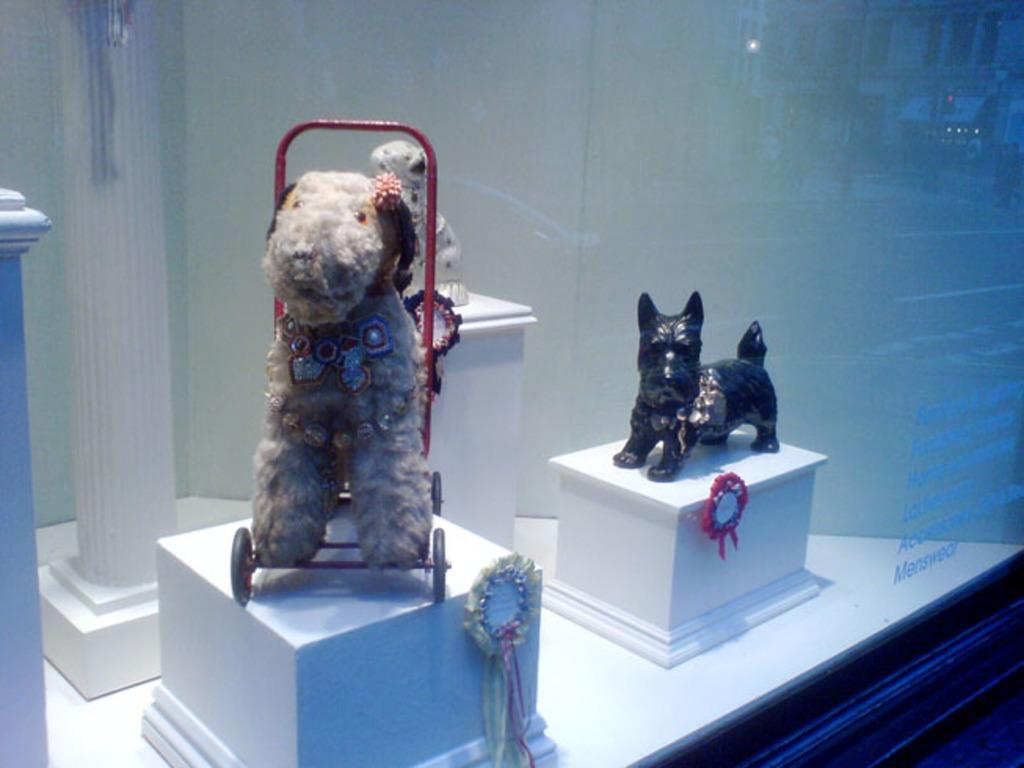What is located at the bottom of the image? There is a table at the bottom of the image. What can be seen above the table in the image? There are objects visible above the table. What type of art pieces are present in the image? There are sculptures present in the image. What architectural feature is visible in the image? There is a pillar in the image. What is visible in the background of the image? There is a wall visible in the background of the image. What type of wool is being spun by the airplane in the image? There is no airplane or wool present in the image. What type of place is depicted in the image? The image does not depict a specific place; it only shows a table, objects, sculptures, a pillar, and a wall. 